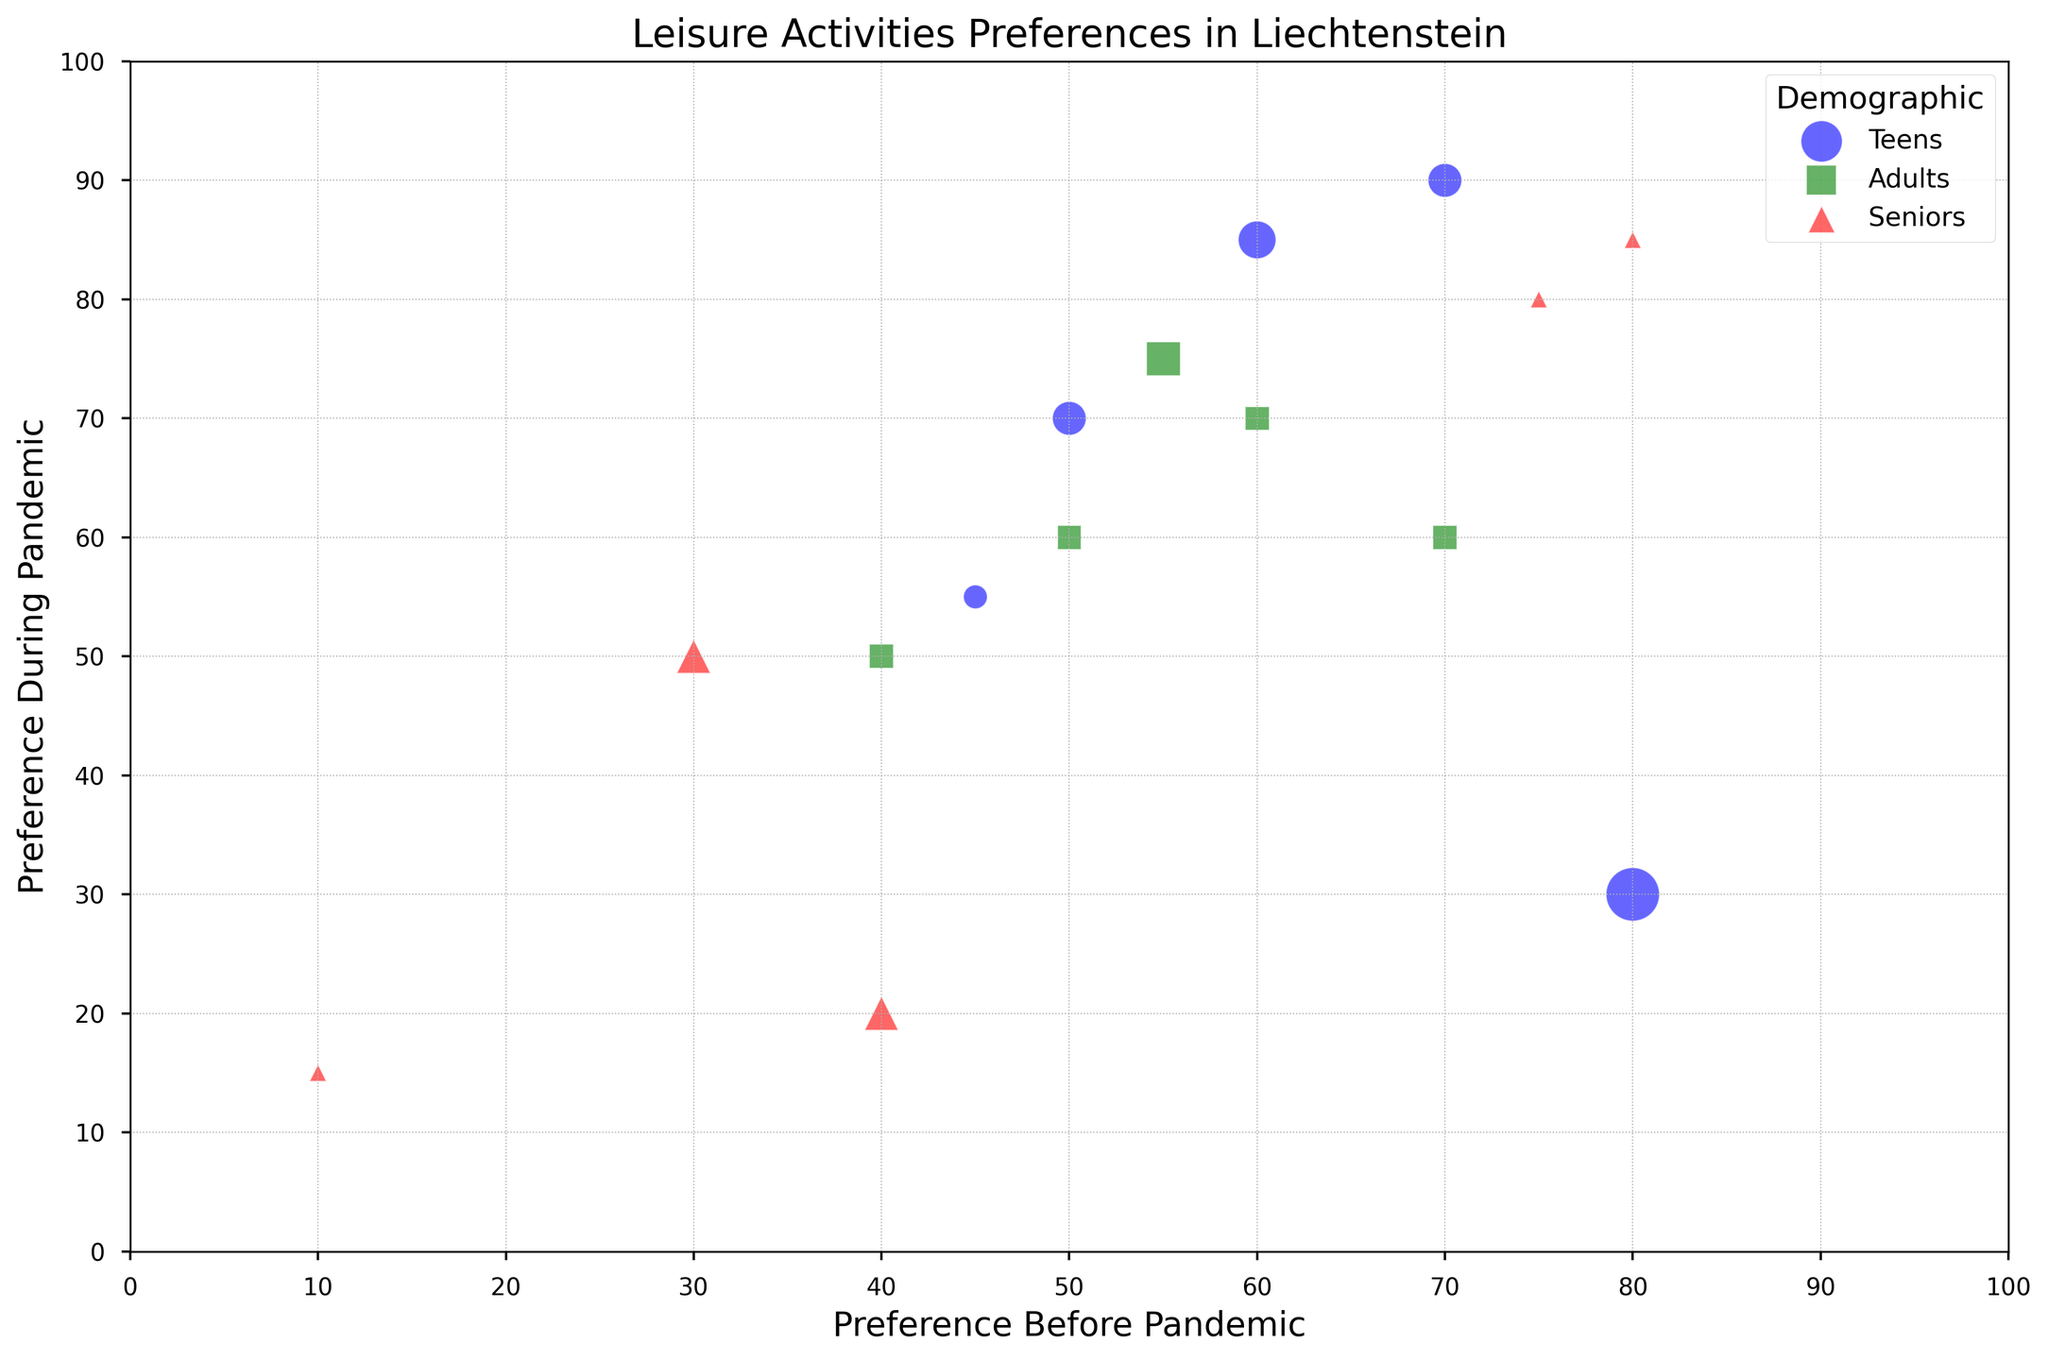Which demographic has the highest preference for video games during the pandemic? By examining the heights of the markers and identifying their labels in the legend, the highest preference for video games during the pandemic corresponds to the 'Teens' demographic.
Answer: Teens Which demographic shows the largest decrease in preference for outdoor sports? By comparing all the 'Outdoor Sports' markers across demographics and checking the difference between their positions along the 'Preference Before Pandemic' and 'Preference During Pandemic' axes, 'Teens' shows the largest decrease.
Answer: Teens What is the average change in preference for watching TV across all demographics? Take the 'Change_in_Preference' values for Watching TV: Teens (+20), Adults (+20), and Seniors (+5). The sum is 20 + 20 + 5 = 45, and the average is 45 / 3 = 15.
Answer: 15 Which activity has the most significant increase in preference among the 'Teens' demographic? By looking at the 'Change_in_Preference' values for 'Teens', Online Socializing has the largest increase with +25.
Answer: Online Socializing Is the preference for reading during the pandemic higher in Adults or Seniors? By comparing the position of the 'Reading' markers along the 'Preference During Pandemic' axis for both Adults and Seniors, the value for Seniors (85) is higher than for Adults (70).
Answer: Seniors What is the combined total preference for online socializing before the pandemic across all demographics? Add the 'Preference_Pre_Pandemic' values for Online Socializing: Teens (60), Adults (50), and Seniors (30). The total is 60 + 50 + 30 = 140.
Answer: 140 Which activity's preference decreased the most among Seniors during the pandemic? Comparing the 'Change_in_Preference' values for Seniors, Outdoor Sports decreased the most with -20.
Answer: Outdoor Sports How does the preference for reading before the pandemic compare between Teens and Adults? By comparing the positions of the 'Reading' markers along the 'Preference Before Pandemic' axis, Teens are at 45, and Adults are at 60. Thus Adults had a higher preference than Teens.
Answer: Adults What is the change in preference for video games among Adults and Seniors combined? Take the 'Change_in_Preference' values for Video Games: Adults (+10) and Seniors (+5). The combined change is 10 + 5 = 15.
Answer: 15 Which demographic has the smallest bubble for watching TV during the pandemic? By observing the sizes of the 'Watching TV' bubbles for all demographics, the smallest bubble, indicating the smallest change, belongs to Seniors.
Answer: Seniors 